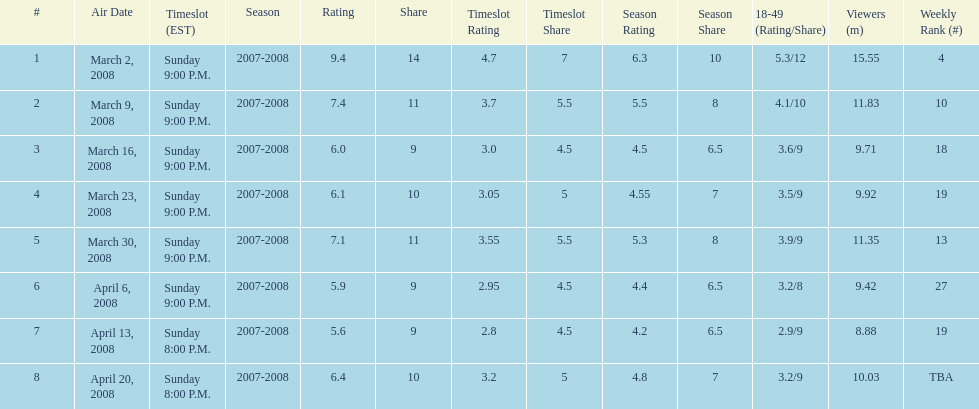How many shows had at least 10 million viewers? 4. 